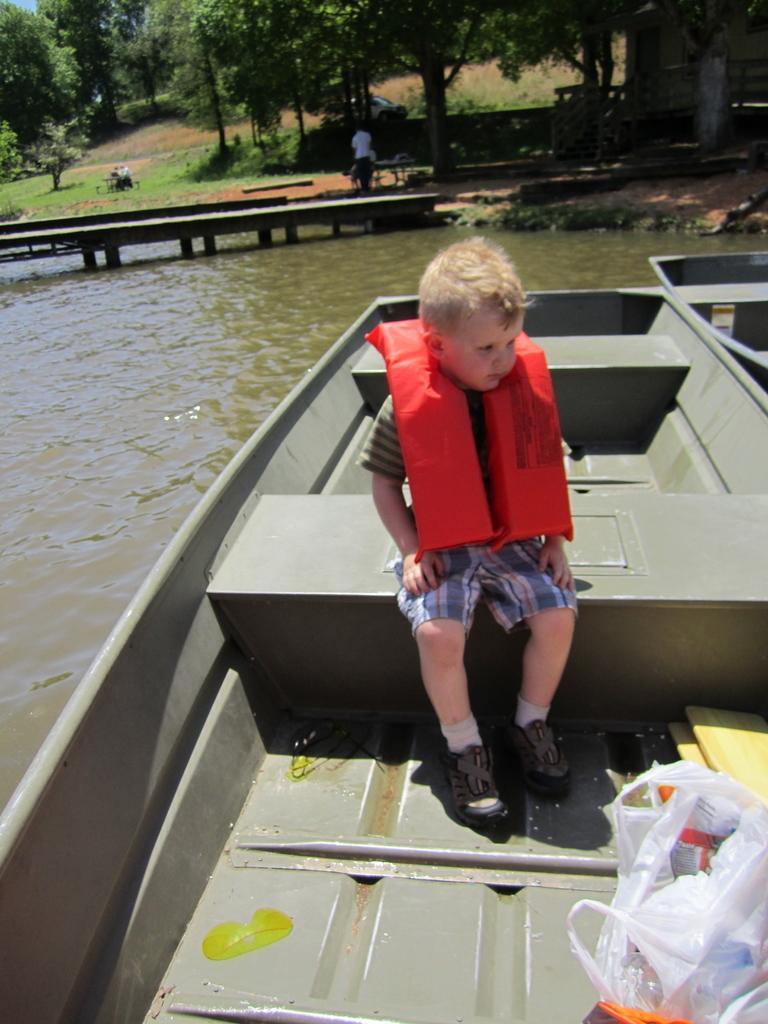Please provide a concise description of this image. In this picture we can observe a boy sitting in the boat wearing an orange color life jacket. We can observe plastic bags on the right side. The boat is floating on the water. In the background there are trees and a wooden bridge on the water. 